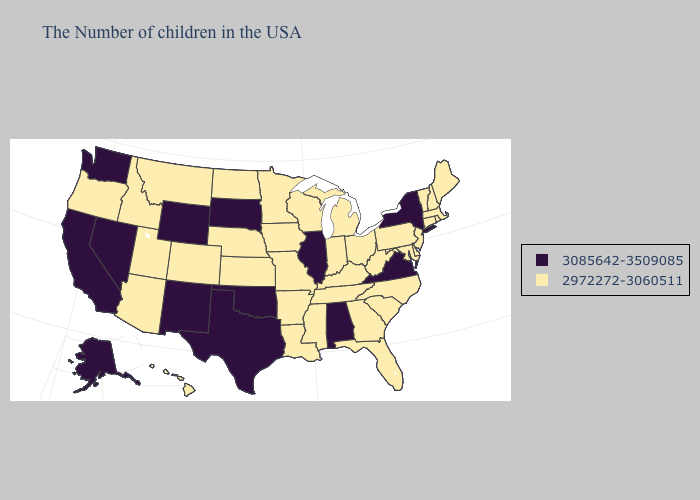Does the first symbol in the legend represent the smallest category?
Short answer required. No. How many symbols are there in the legend?
Quick response, please. 2. Which states have the lowest value in the Northeast?
Quick response, please. Maine, Massachusetts, Rhode Island, New Hampshire, Vermont, Connecticut, New Jersey, Pennsylvania. What is the highest value in the Northeast ?
Be succinct. 3085642-3509085. Does Alaska have the lowest value in the USA?
Keep it brief. No. Does New York have the highest value in the Northeast?
Answer briefly. Yes. What is the value of Pennsylvania?
Be succinct. 2972272-3060511. Which states hav the highest value in the West?
Be succinct. Wyoming, New Mexico, Nevada, California, Washington, Alaska. What is the value of Pennsylvania?
Short answer required. 2972272-3060511. Name the states that have a value in the range 2972272-3060511?
Write a very short answer. Maine, Massachusetts, Rhode Island, New Hampshire, Vermont, Connecticut, New Jersey, Delaware, Maryland, Pennsylvania, North Carolina, South Carolina, West Virginia, Ohio, Florida, Georgia, Michigan, Kentucky, Indiana, Tennessee, Wisconsin, Mississippi, Louisiana, Missouri, Arkansas, Minnesota, Iowa, Kansas, Nebraska, North Dakota, Colorado, Utah, Montana, Arizona, Idaho, Oregon, Hawaii. What is the highest value in states that border Nebraska?
Keep it brief. 3085642-3509085. Name the states that have a value in the range 2972272-3060511?
Write a very short answer. Maine, Massachusetts, Rhode Island, New Hampshire, Vermont, Connecticut, New Jersey, Delaware, Maryland, Pennsylvania, North Carolina, South Carolina, West Virginia, Ohio, Florida, Georgia, Michigan, Kentucky, Indiana, Tennessee, Wisconsin, Mississippi, Louisiana, Missouri, Arkansas, Minnesota, Iowa, Kansas, Nebraska, North Dakota, Colorado, Utah, Montana, Arizona, Idaho, Oregon, Hawaii. What is the value of Vermont?
Keep it brief. 2972272-3060511. What is the value of New Jersey?
Write a very short answer. 2972272-3060511. Name the states that have a value in the range 3085642-3509085?
Be succinct. New York, Virginia, Alabama, Illinois, Oklahoma, Texas, South Dakota, Wyoming, New Mexico, Nevada, California, Washington, Alaska. 